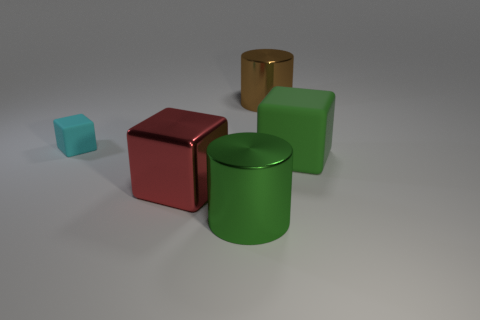There is another large object that is the same color as the big rubber thing; what shape is it?
Offer a terse response. Cylinder. Is there a big object of the same color as the large rubber cube?
Ensure brevity in your answer.  Yes. What number of other objects are the same material as the small cyan object?
Give a very brief answer. 1. Is the material of the big green thing in front of the green rubber thing the same as the cyan thing?
Make the answer very short. No. What is the shape of the large red object?
Your answer should be compact. Cube. Are there more matte things in front of the tiny cyan thing than brown metallic blocks?
Keep it short and to the point. Yes. What is the color of the other big thing that is the same shape as the brown thing?
Ensure brevity in your answer.  Green. What shape is the green metallic object that is on the left side of the large green matte thing?
Provide a short and direct response. Cylinder. There is a cyan rubber block; are there any large brown cylinders behind it?
Provide a short and direct response. Yes. Is there anything else that is the same size as the cyan matte block?
Provide a short and direct response. No. 